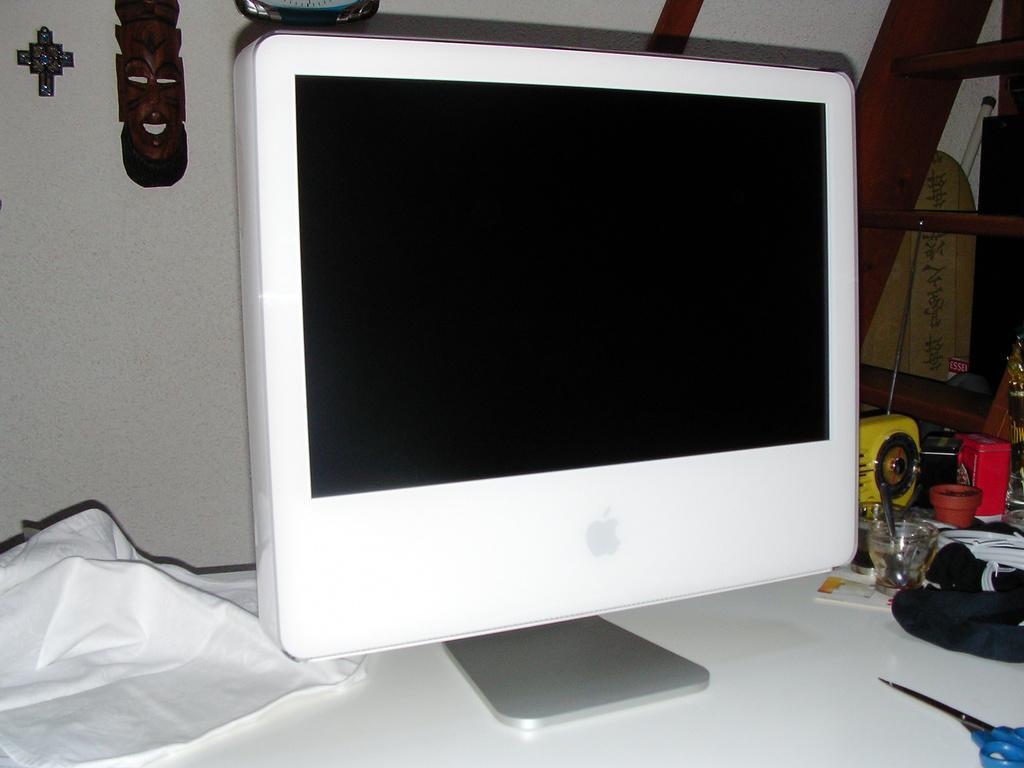Could you give a brief overview of what you see in this image? In the picture we can see an apple monitor which is placed on the white color table and near it, we can see a scissors and something and on the other side of the monitor we can see a white color tissue and behind the monitor we can see a wall with some crafts and some wooden steps near the wall. 